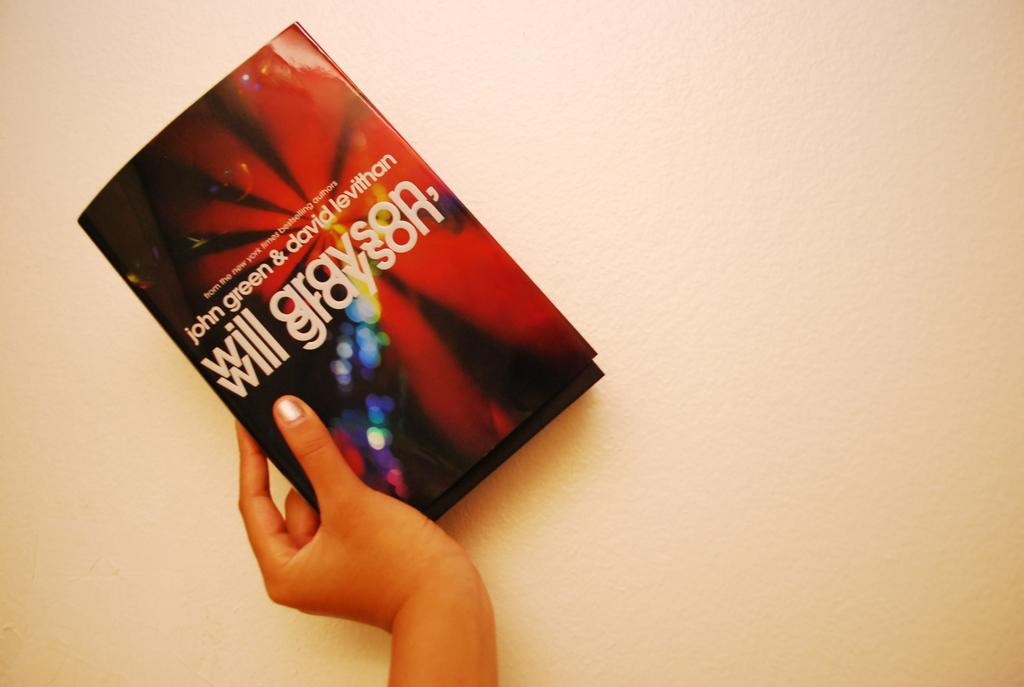<image>
Present a compact description of the photo's key features. A hand holds a book called Will Grayson by Green and Levithan which has a colourful cover. 